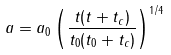<formula> <loc_0><loc_0><loc_500><loc_500>a = a _ { 0 } \left ( \frac { t ( t + t _ { c } ) } { t _ { 0 } ( t _ { 0 } + t _ { c } ) } \right ) ^ { 1 / 4 } \</formula> 